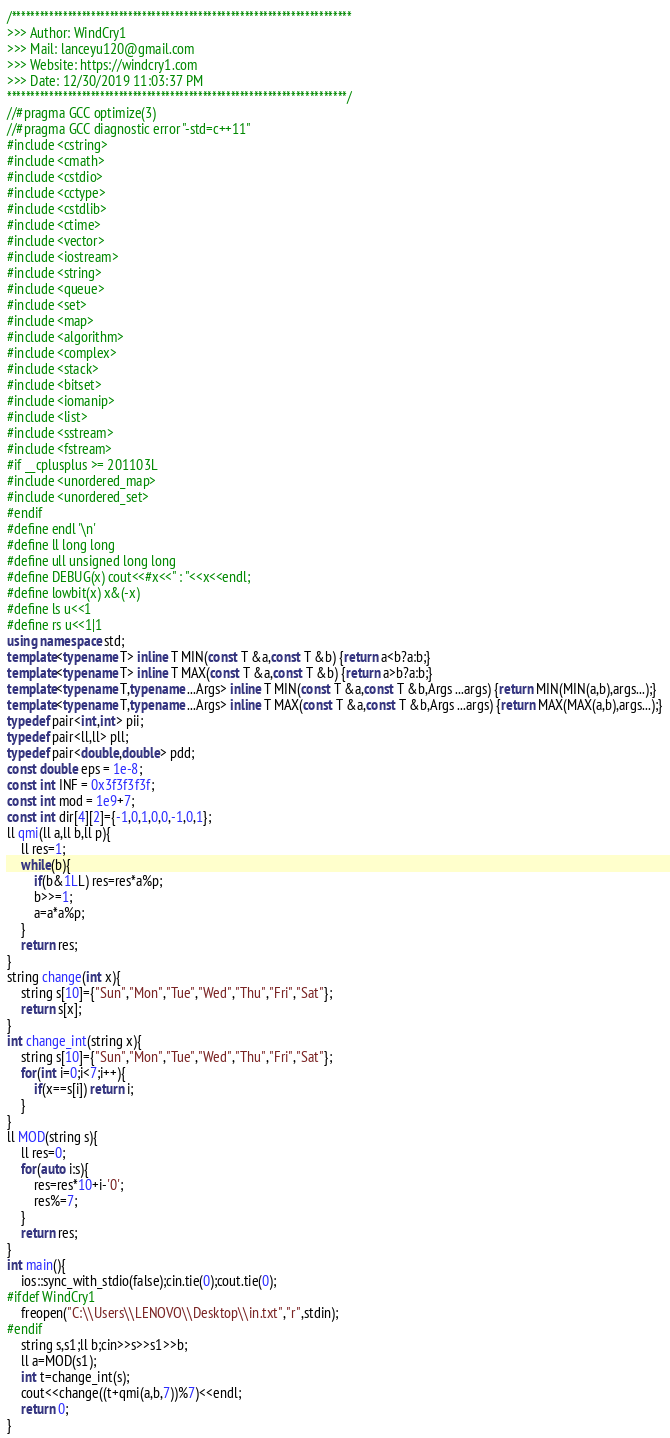<code> <loc_0><loc_0><loc_500><loc_500><_C++_>/*************************************************************************
>>> Author: WindCry1
>>> Mail: lanceyu120@gmail.com
>>> Website: https://windcry1.com
>>> Date: 12/30/2019 11:03:37 PM
*************************************************************************/
//#pragma GCC optimize(3)
//#pragma GCC diagnostic error "-std=c++11"
#include <cstring>
#include <cmath>
#include <cstdio>
#include <cctype>
#include <cstdlib>
#include <ctime>
#include <vector>
#include <iostream>
#include <string>
#include <queue>
#include <set>
#include <map>
#include <algorithm>
#include <complex>
#include <stack>
#include <bitset>
#include <iomanip>
#include <list>
#include <sstream>
#include <fstream>
#if __cplusplus >= 201103L
#include <unordered_map>
#include <unordered_set>
#endif
#define endl '\n'
#define ll long long
#define ull unsigned long long
#define DEBUG(x) cout<<#x<<" : "<<x<<endl;
#define lowbit(x) x&(-x)
#define ls u<<1
#define rs u<<1|1
using namespace std;
template<typename T> inline T MIN(const T &a,const T &b) {return a<b?a:b;}
template<typename T> inline T MAX(const T &a,const T &b) {return a>b?a:b;}
template<typename T,typename ...Args> inline T MIN(const T &a,const T &b,Args ...args) {return MIN(MIN(a,b),args...);}
template<typename T,typename ...Args> inline T MAX(const T &a,const T &b,Args ...args) {return MAX(MAX(a,b),args...);}
typedef pair<int,int> pii;
typedef pair<ll,ll> pll;
typedef pair<double,double> pdd;
const double eps = 1e-8;
const int INF = 0x3f3f3f3f;
const int mod = 1e9+7;
const int dir[4][2]={-1,0,1,0,0,-1,0,1};
ll qmi(ll a,ll b,ll p){
	ll res=1;
	while(b){
		if(b&1LL) res=res*a%p;
		b>>=1;
		a=a*a%p;
	}
	return res;
}
string change(int x){
	string s[10]={"Sun","Mon","Tue","Wed","Thu","Fri","Sat"};
	return s[x];
}
int change_int(string x){
	string s[10]={"Sun","Mon","Tue","Wed","Thu","Fri","Sat"};
	for(int i=0;i<7;i++){
		if(x==s[i]) return i;
	}
}
ll MOD(string s){
	ll res=0;
	for(auto i:s){
		res=res*10+i-'0';
		res%=7;
	}
	return res;
}
int main(){
	ios::sync_with_stdio(false);cin.tie(0);cout.tie(0);
#ifdef WindCry1
	freopen("C:\\Users\\LENOVO\\Desktop\\in.txt","r",stdin);
#endif
	string s,s1;ll b;cin>>s>>s1>>b;
	ll a=MOD(s1);
	int t=change_int(s);
	cout<<change((t+qmi(a,b,7))%7)<<endl;
	return 0;
}


</code> 